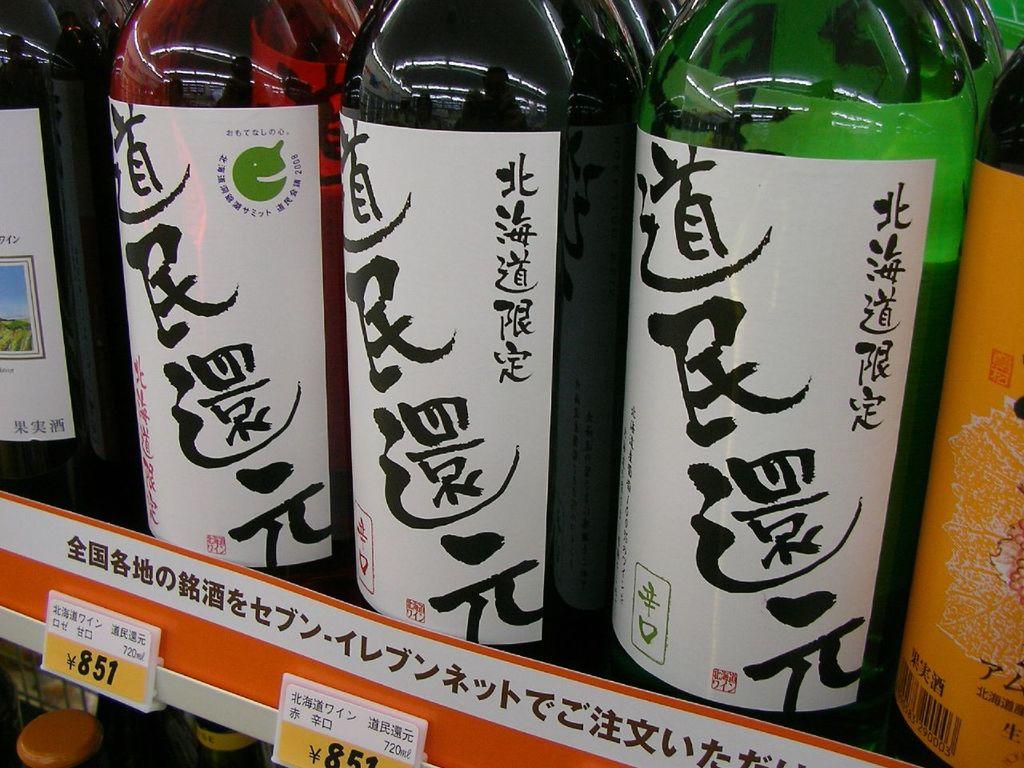What number is on the price tag?
Your response must be concise. 851. 